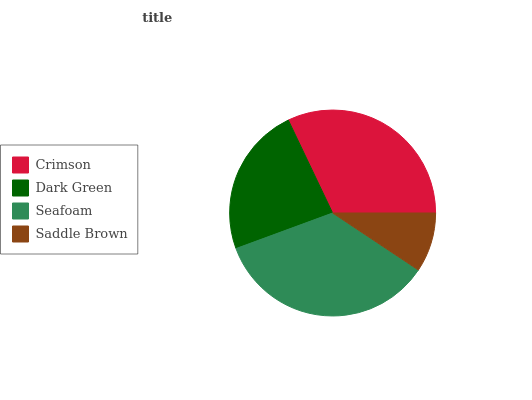Is Saddle Brown the minimum?
Answer yes or no. Yes. Is Seafoam the maximum?
Answer yes or no. Yes. Is Dark Green the minimum?
Answer yes or no. No. Is Dark Green the maximum?
Answer yes or no. No. Is Crimson greater than Dark Green?
Answer yes or no. Yes. Is Dark Green less than Crimson?
Answer yes or no. Yes. Is Dark Green greater than Crimson?
Answer yes or no. No. Is Crimson less than Dark Green?
Answer yes or no. No. Is Crimson the high median?
Answer yes or no. Yes. Is Dark Green the low median?
Answer yes or no. Yes. Is Dark Green the high median?
Answer yes or no. No. Is Saddle Brown the low median?
Answer yes or no. No. 